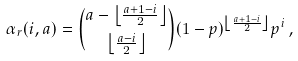Convert formula to latex. <formula><loc_0><loc_0><loc_500><loc_500>\alpha _ { r } ( i , a ) = { a - \left \lfloor \frac { a + 1 - i } { 2 } \right \rfloor \choose \left \lfloor \frac { a - i } { 2 } \right \rfloor } ( 1 - p ) ^ { \left \lfloor \frac { a + 1 - i } { 2 } \right \rfloor } p ^ { i } \, ,</formula> 